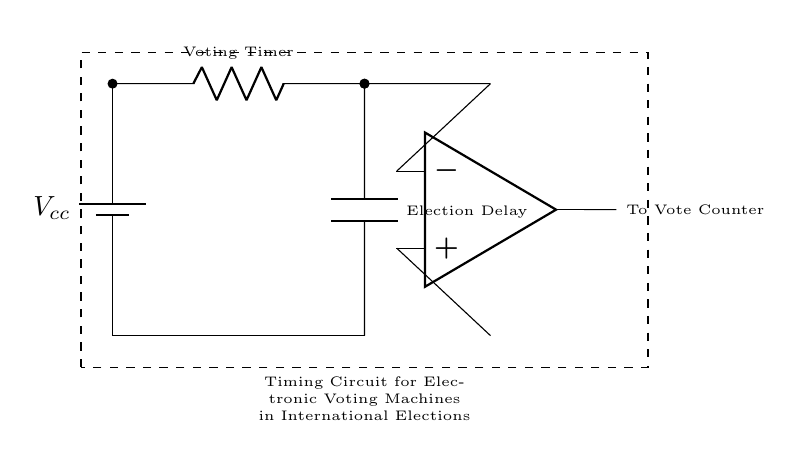What is the function of the resistor in this circuit? The resistor, labeled as the Voting Timer, controls the timing aspect of the circuit, impacting how long the voting machine waits before proceeding to the next step. This is critical in managing the time allowed for voters to complete their process.
Answer: Voting Timer What type of capacitor is used in this circuit? While the specific type of capacitor is not labeled, it is generally used as an Election Delay component, which indicates a timing function to ensure the appropriate delay between voting operations.
Answer: Election Delay What is the main purpose of this timing circuit? The timing circuit is designed to manage the operations in electronic voting machines, ensuring that vote counts are recorded after a defined period, critical for proper functioning during elections.
Answer: Manage voting operations Which component connects to the vote counter? The op-amp output connects to the vote counter, indicating that it processes the amplified voting signal before reporting the vote total. This connection is essential for transmitting the final count.
Answer: Op-amp How many components directly connect to the battery? There is one component that directly connects to the battery: the Voting Timer resistor. This connection powers the entire timing circuit, allowing it to function properly.
Answer: One What is the input voltage for this circuit? The input voltage is represented by Vcc, which implies a supply voltage necessary for the operation of all components in the circuit. This voltage is crucial for providing the needed potential for functioning.
Answer: Vcc 